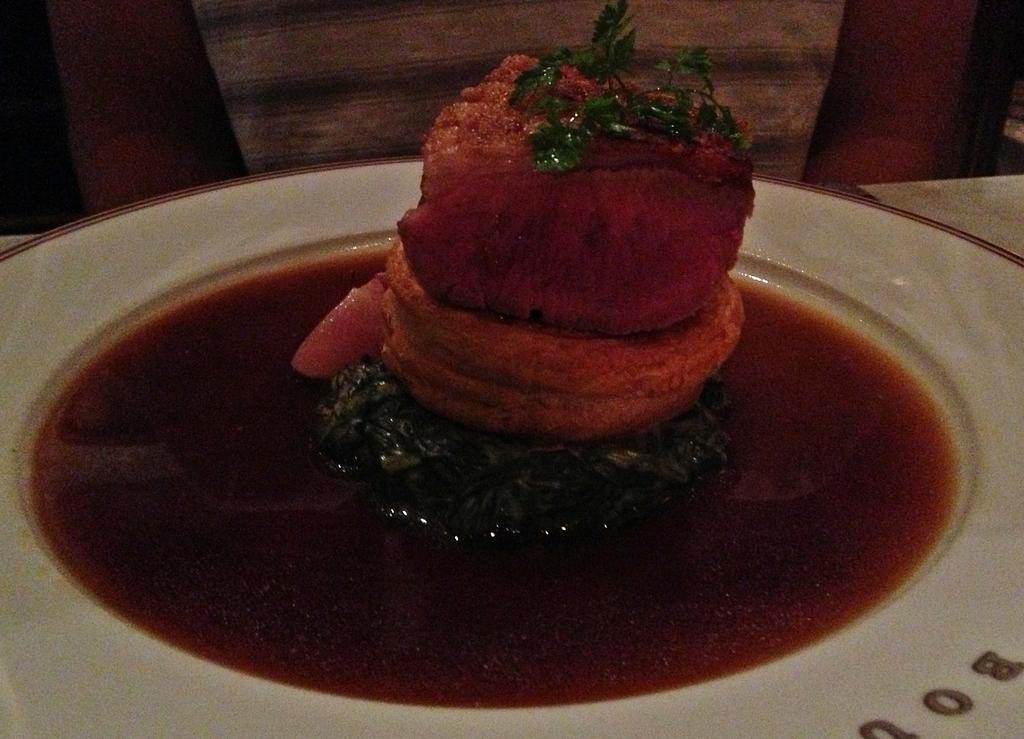How would you summarize this image in a sentence or two? In the center of the image we can see a plate. In the plate, we can see some liquid and some food items. At the bottom right side of the image, we can see capital letters. In the background, we can see a few other objects. 